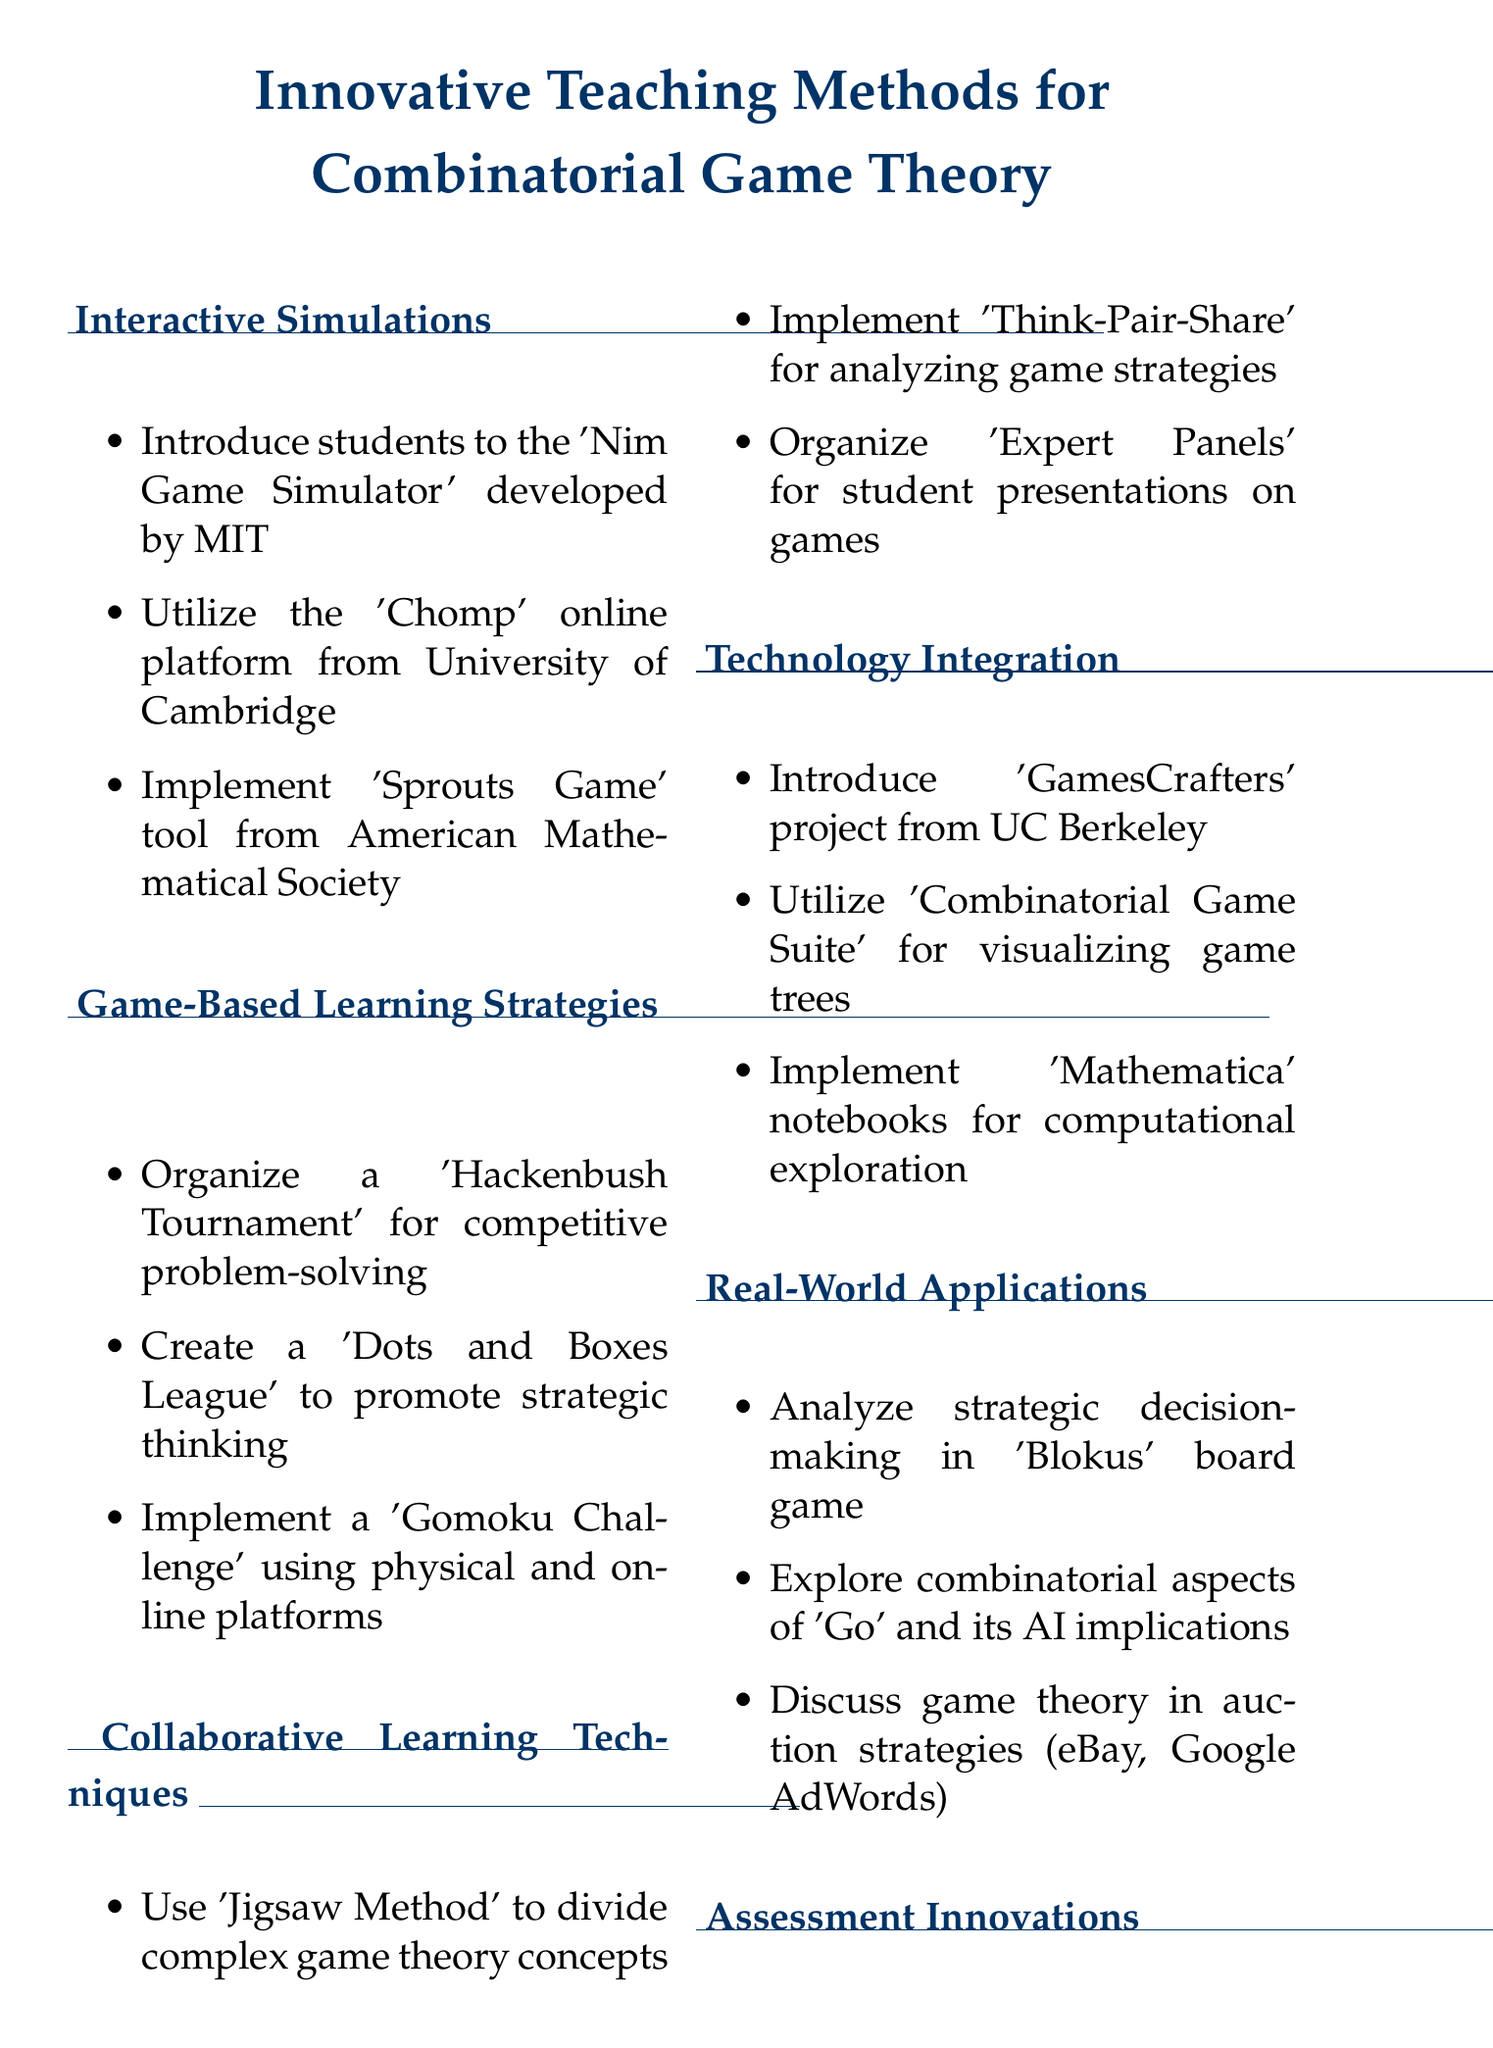what game simulator is developed by MIT? The document lists the 'Nim Game Simulator' as the game simulator developed by MIT.
Answer: Nim Game Simulator what competitive event is suggested for students? The document suggests organizing a 'Hackenbush Tournament' as a competitive event for students.
Answer: Hackenbush Tournament what method is used to divide complex game theory concepts? The document mentions using the 'Jigsaw Method' to divide complex game theory concepts among student groups.
Answer: Jigsaw Method which software is recommended for visualizing game trees? The document recommends using the 'Combinatorial Game Suite' software for visualizing game trees.
Answer: Combinatorial Game Suite what are students encouraged to present in 'Expert Panels'? The document states that students are encouraged to present different combinatorial games in 'Expert Panels'.
Answer: combinatorial games what project is introduced for algorithmic game analysis? The document introduces the 'GamesCrafters' project from UC Berkeley for algorithmic game analysis.
Answer: GamesCrafters how can students assess each other's game strategies? According to the document, students can assess each other's game strategies through 'Peer Evaluation' techniques.
Answer: Peer Evaluation which game is analyzed as a case study for strategic decision-making? The document mentions analyzing the strategic decision-making in the board game 'Blokus' as a case study.
Answer: Blokus what learning technique involves 'Think-Pair-Share'? The document indicates that 'Think-Pair-Share' activities are implemented for analyzing game strategies in real-time.
Answer: analyzing game strategies 